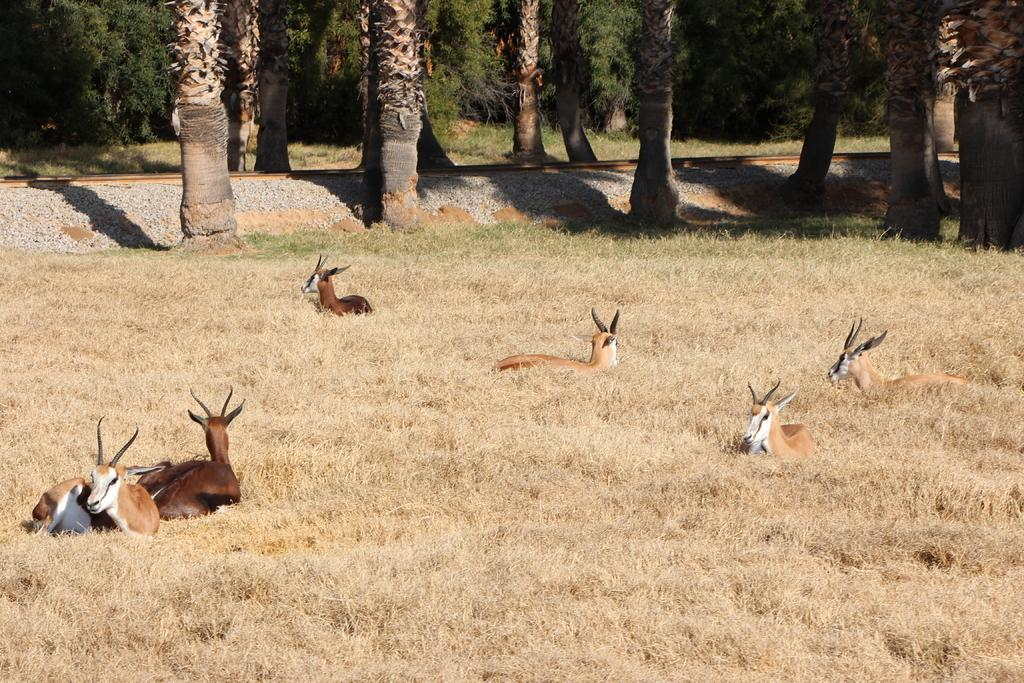What types of living organisms are present in the image? There are animals in the image. What type of vegetation can be seen in the image? There is dried grass in the image. What can be seen in the background of the image? There are trees and stones in the background of the image. What type of tooth is visible in the image? There is no tooth present in the image. What is the root of the tree in the image? There is no tree with a visible root in the image. 